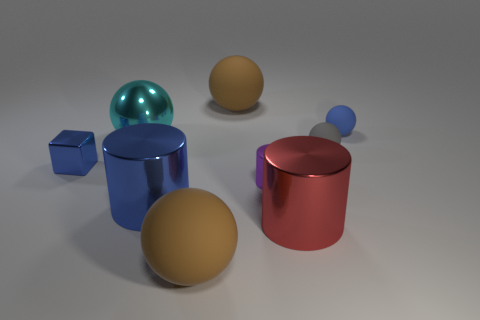Do the red object and the tiny purple metallic thing that is on the right side of the blue cylinder have the same shape?
Keep it short and to the point. Yes. How many objects are both to the right of the metallic block and on the left side of the tiny gray rubber thing?
Provide a succinct answer. 6. What number of yellow objects are either metal objects or large spheres?
Your answer should be compact. 0. Does the big matte ball in front of the gray rubber ball have the same color as the small matte object that is behind the gray rubber thing?
Provide a short and direct response. No. There is a large rubber object behind the tiny thing on the left side of the brown object in front of the metal block; what color is it?
Your answer should be very brief. Brown. There is a large metal object that is behind the small cube; are there any tiny purple metallic objects to the right of it?
Provide a succinct answer. Yes. There is a big shiny thing that is on the right side of the large blue metallic object; does it have the same shape as the cyan metallic thing?
Make the answer very short. No. Are there any other things that are the same shape as the gray object?
Offer a terse response. Yes. What number of cylinders are blue metal things or rubber things?
Your answer should be very brief. 1. How many large green things are there?
Your answer should be very brief. 0. 